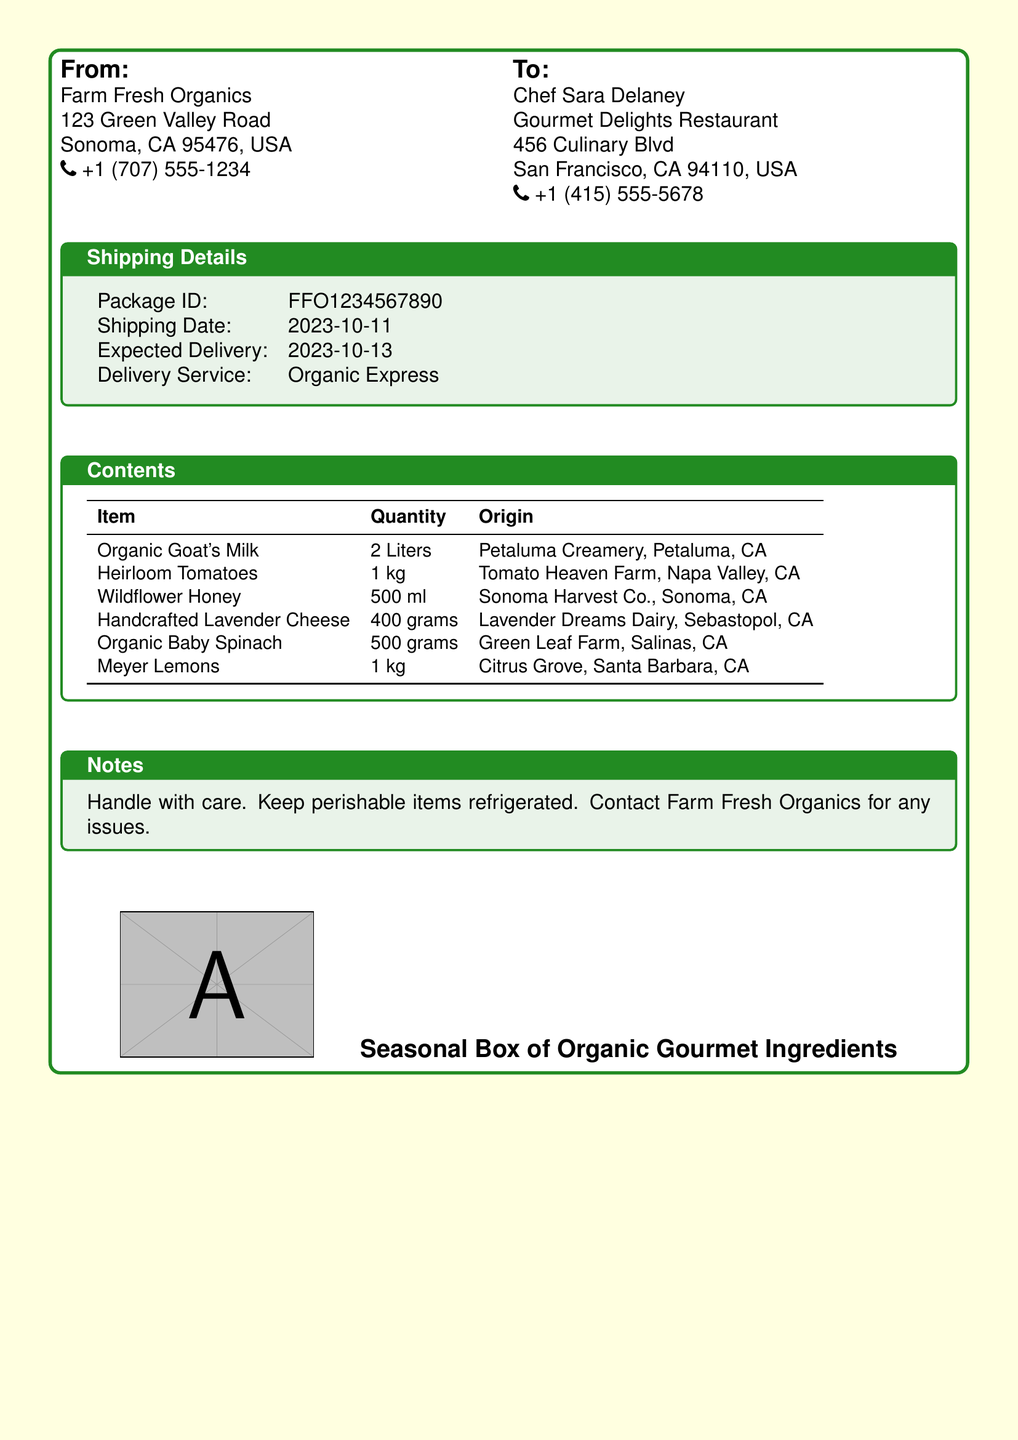What is the package ID? The package ID is listed under the shipping details section of the document.
Answer: FFO1234567890 Who is the sender? The sender's information is found in the "From" section of the document.
Answer: Farm Fresh Organics What is the expected delivery date? The expected delivery date is detailed in the shipping details section.
Answer: 2023-10-13 How many liters of Organic Goat's Milk are included? The quantity of Organic Goat's Milk is specified in the contents table.
Answer: 2 Liters Where is the Handcrafted Lavender Cheese sourced from? The origin of the Handcrafted Lavender Cheese is provided in the contents table.
Answer: Lavender Dreams Dairy, Sebastopol, CA What delivery service is being used? The delivery service is noted in the shipping details section of the document.
Answer: Organic Express Which item has the highest quantity? By comparing the quantities of all items, we can determine which has the highest amount listed.
Answer: Heirloom Tomatoes What should you do with perishable items? The notes section provides guidance on handling perishable items.
Answer: Keep refrigerated What is the total quantity of Meyer Lemons? The quantity of Meyer Lemons is stated in the contents table of the document.
Answer: 1 kg 